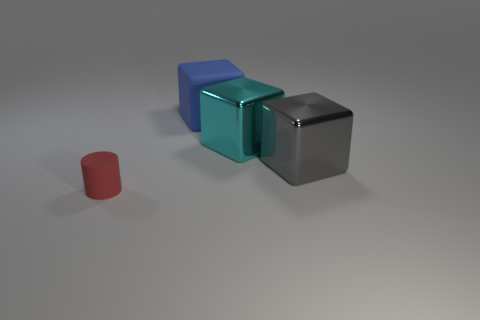There is a large rubber object; is its color the same as the rubber object left of the blue cube?
Provide a succinct answer. No. What is the color of the object that is left of the big cyan metallic object and in front of the large blue rubber block?
Your answer should be compact. Red. There is a big matte cube; how many big things are to the left of it?
Offer a very short reply. 0. What number of things are brown objects or things behind the gray metal thing?
Your response must be concise. 2. Is there a tiny matte object behind the metal thing behind the gray metal block?
Offer a very short reply. No. There is a matte thing right of the small rubber cylinder; what is its color?
Your answer should be compact. Blue. Are there the same number of red objects behind the tiny red thing and big blue shiny cubes?
Provide a short and direct response. Yes. The thing that is both on the right side of the blue cube and in front of the cyan block has what shape?
Provide a succinct answer. Cube. There is another shiny thing that is the same shape as the cyan shiny object; what color is it?
Offer a terse response. Gray. Are there any other things of the same color as the small rubber cylinder?
Your answer should be compact. No. 